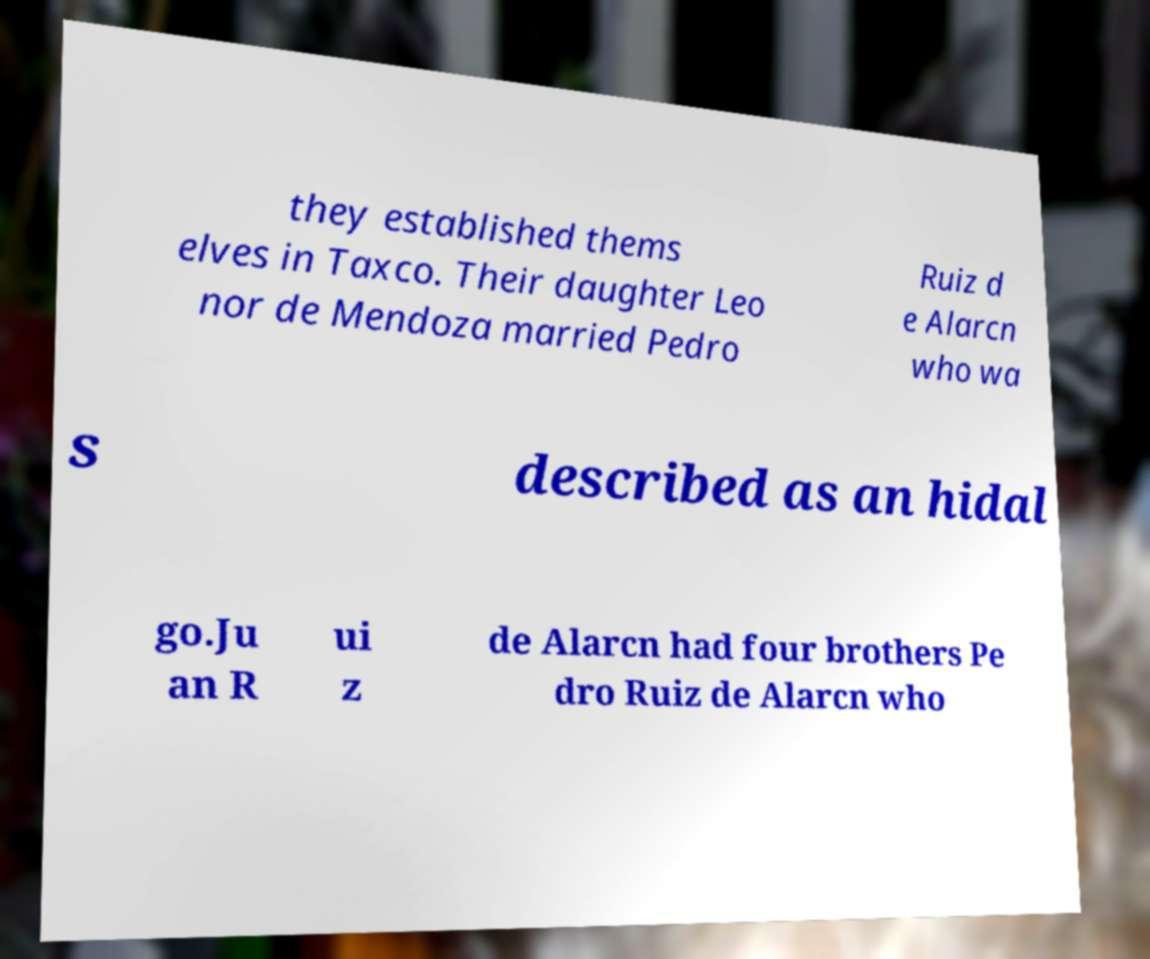For documentation purposes, I need the text within this image transcribed. Could you provide that? they established thems elves in Taxco. Their daughter Leo nor de Mendoza married Pedro Ruiz d e Alarcn who wa s described as an hidal go.Ju an R ui z de Alarcn had four brothers Pe dro Ruiz de Alarcn who 